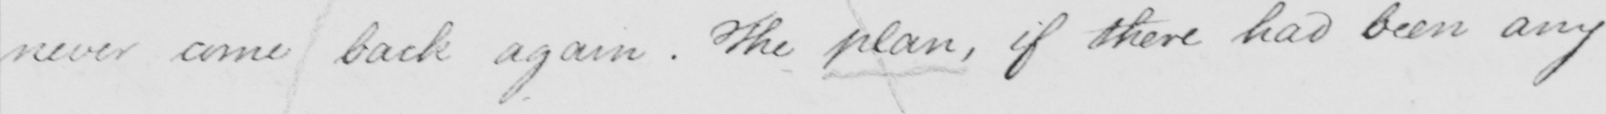Transcribe the text shown in this historical manuscript line. never come back again. The plan, if there had been any 